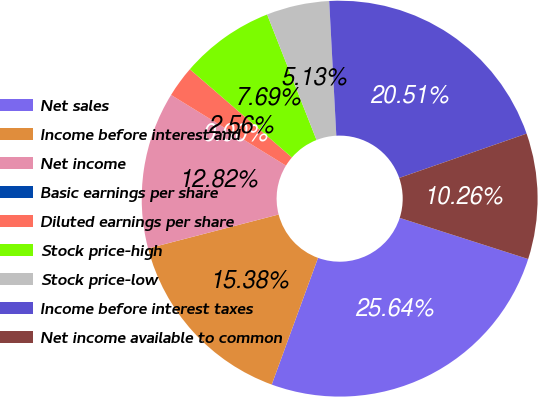<chart> <loc_0><loc_0><loc_500><loc_500><pie_chart><fcel>Net sales<fcel>Income before interest and<fcel>Net income<fcel>Basic earnings per share<fcel>Diluted earnings per share<fcel>Stock price-high<fcel>Stock price-low<fcel>Income before interest taxes<fcel>Net income available to common<nl><fcel>25.64%<fcel>15.38%<fcel>12.82%<fcel>0.0%<fcel>2.56%<fcel>7.69%<fcel>5.13%<fcel>20.51%<fcel>10.26%<nl></chart> 